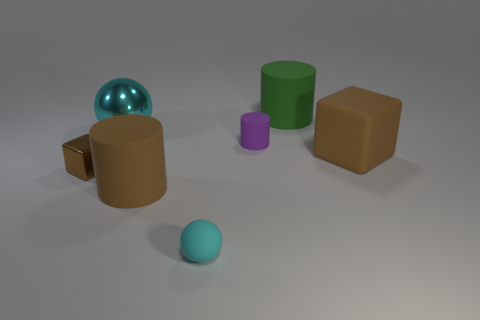What is the size of the brown cylinder that is made of the same material as the large green object?
Offer a very short reply. Large. There is a cyan thing that is in front of the large ball; what is its shape?
Provide a succinct answer. Sphere. There is a shiny ball that is the same size as the brown matte cylinder; what color is it?
Your answer should be very brief. Cyan. Do the tiny cyan object and the brown object left of the big metal thing have the same shape?
Offer a terse response. No. What material is the big brown thing to the left of the big rubber cylinder on the right side of the cylinder in front of the big brown rubber block?
Provide a succinct answer. Rubber. What number of small things are green objects or rubber spheres?
Your response must be concise. 1. What number of other things are there of the same size as the purple object?
Give a very brief answer. 2. Do the small shiny thing on the left side of the cyan rubber ball and the small cyan thing have the same shape?
Make the answer very short. No. What color is the other large rubber thing that is the same shape as the big green object?
Keep it short and to the point. Brown. Are there an equal number of tiny cylinders that are in front of the big brown rubber cube and large shiny cylinders?
Provide a short and direct response. Yes. 